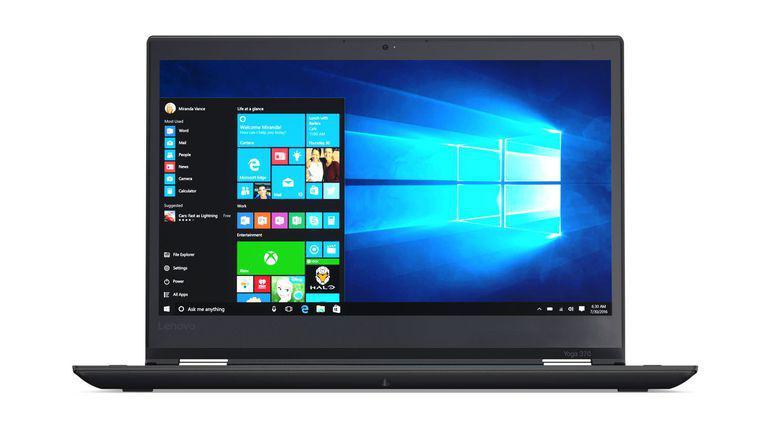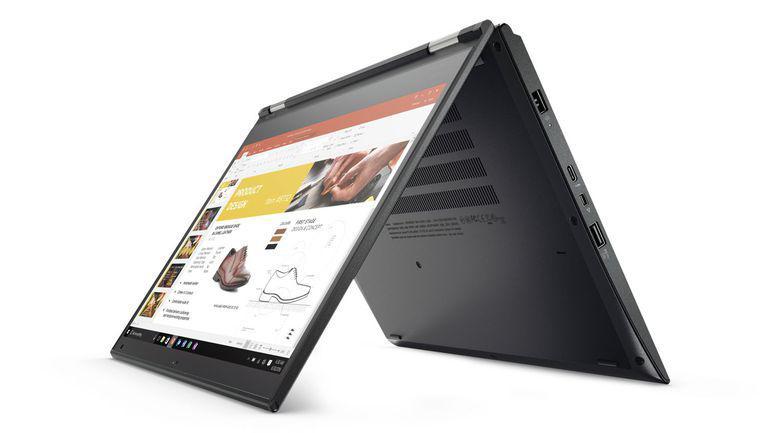The first image is the image on the left, the second image is the image on the right. Assess this claim about the two images: "Each image shows an open tablet laptop sitting flat on its keyboard base, with a picture on its screen, and at least one image shows the screen reversed so the picture is on the back.". Correct or not? Answer yes or no. No. The first image is the image on the left, the second image is the image on the right. Considering the images on both sides, is "Every laptop is shown on a solid white background." valid? Answer yes or no. Yes. 